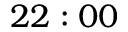Convert formula to latex. <formula><loc_0><loc_0><loc_500><loc_500>2 2 \colon 0 0</formula> 